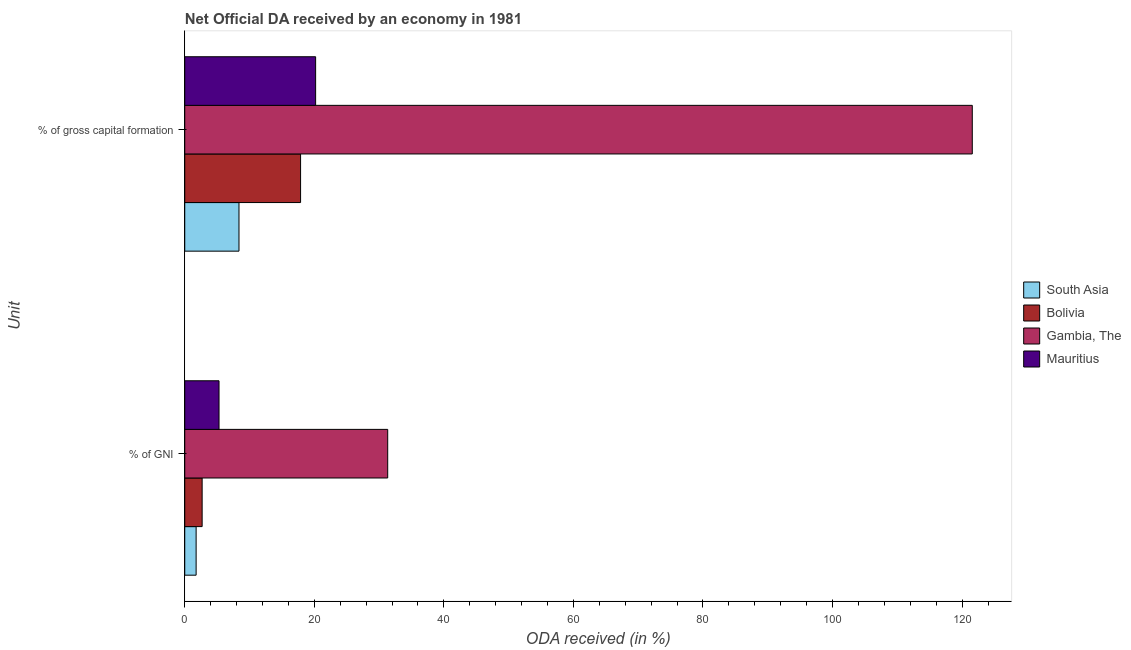Are the number of bars on each tick of the Y-axis equal?
Provide a succinct answer. Yes. What is the label of the 1st group of bars from the top?
Make the answer very short. % of gross capital formation. What is the oda received as percentage of gross capital formation in Bolivia?
Offer a terse response. 17.88. Across all countries, what is the maximum oda received as percentage of gni?
Your response must be concise. 31.33. Across all countries, what is the minimum oda received as percentage of gross capital formation?
Ensure brevity in your answer.  8.37. In which country was the oda received as percentage of gni maximum?
Make the answer very short. Gambia, The. In which country was the oda received as percentage of gni minimum?
Offer a very short reply. South Asia. What is the total oda received as percentage of gross capital formation in the graph?
Give a very brief answer. 168.03. What is the difference between the oda received as percentage of gross capital formation in Gambia, The and that in Bolivia?
Offer a terse response. 103.7. What is the difference between the oda received as percentage of gni in Bolivia and the oda received as percentage of gross capital formation in Gambia, The?
Ensure brevity in your answer.  -118.89. What is the average oda received as percentage of gni per country?
Keep it short and to the point. 10.27. What is the difference between the oda received as percentage of gni and oda received as percentage of gross capital formation in South Asia?
Provide a succinct answer. -6.62. What is the ratio of the oda received as percentage of gross capital formation in South Asia to that in Mauritius?
Your response must be concise. 0.41. What does the 2nd bar from the top in % of GNI represents?
Ensure brevity in your answer.  Gambia, The. How many bars are there?
Your answer should be compact. 8. Are all the bars in the graph horizontal?
Make the answer very short. Yes. Are the values on the major ticks of X-axis written in scientific E-notation?
Keep it short and to the point. No. Where does the legend appear in the graph?
Your response must be concise. Center right. How many legend labels are there?
Offer a very short reply. 4. What is the title of the graph?
Provide a short and direct response. Net Official DA received by an economy in 1981. Does "Mongolia" appear as one of the legend labels in the graph?
Give a very brief answer. No. What is the label or title of the X-axis?
Provide a short and direct response. ODA received (in %). What is the label or title of the Y-axis?
Provide a succinct answer. Unit. What is the ODA received (in %) in South Asia in % of GNI?
Ensure brevity in your answer.  1.76. What is the ODA received (in %) of Bolivia in % of GNI?
Your answer should be very brief. 2.68. What is the ODA received (in %) of Gambia, The in % of GNI?
Ensure brevity in your answer.  31.33. What is the ODA received (in %) of Mauritius in % of GNI?
Provide a short and direct response. 5.29. What is the ODA received (in %) in South Asia in % of gross capital formation?
Provide a short and direct response. 8.37. What is the ODA received (in %) of Bolivia in % of gross capital formation?
Your answer should be very brief. 17.88. What is the ODA received (in %) of Gambia, The in % of gross capital formation?
Provide a short and direct response. 121.58. What is the ODA received (in %) of Mauritius in % of gross capital formation?
Your answer should be compact. 20.2. Across all Unit, what is the maximum ODA received (in %) of South Asia?
Your answer should be compact. 8.37. Across all Unit, what is the maximum ODA received (in %) of Bolivia?
Your answer should be very brief. 17.88. Across all Unit, what is the maximum ODA received (in %) of Gambia, The?
Provide a short and direct response. 121.58. Across all Unit, what is the maximum ODA received (in %) of Mauritius?
Your answer should be compact. 20.2. Across all Unit, what is the minimum ODA received (in %) of South Asia?
Ensure brevity in your answer.  1.76. Across all Unit, what is the minimum ODA received (in %) in Bolivia?
Provide a succinct answer. 2.68. Across all Unit, what is the minimum ODA received (in %) in Gambia, The?
Your answer should be compact. 31.33. Across all Unit, what is the minimum ODA received (in %) of Mauritius?
Ensure brevity in your answer.  5.29. What is the total ODA received (in %) of South Asia in the graph?
Your response must be concise. 10.13. What is the total ODA received (in %) of Bolivia in the graph?
Offer a very short reply. 20.56. What is the total ODA received (in %) of Gambia, The in the graph?
Offer a very short reply. 152.91. What is the total ODA received (in %) of Mauritius in the graph?
Make the answer very short. 25.49. What is the difference between the ODA received (in %) of South Asia in % of GNI and that in % of gross capital formation?
Provide a succinct answer. -6.62. What is the difference between the ODA received (in %) in Bolivia in % of GNI and that in % of gross capital formation?
Keep it short and to the point. -15.19. What is the difference between the ODA received (in %) in Gambia, The in % of GNI and that in % of gross capital formation?
Give a very brief answer. -90.24. What is the difference between the ODA received (in %) of Mauritius in % of GNI and that in % of gross capital formation?
Provide a short and direct response. -14.91. What is the difference between the ODA received (in %) in South Asia in % of GNI and the ODA received (in %) in Bolivia in % of gross capital formation?
Provide a short and direct response. -16.12. What is the difference between the ODA received (in %) of South Asia in % of GNI and the ODA received (in %) of Gambia, The in % of gross capital formation?
Keep it short and to the point. -119.82. What is the difference between the ODA received (in %) of South Asia in % of GNI and the ODA received (in %) of Mauritius in % of gross capital formation?
Your answer should be very brief. -18.45. What is the difference between the ODA received (in %) of Bolivia in % of GNI and the ODA received (in %) of Gambia, The in % of gross capital formation?
Keep it short and to the point. -118.89. What is the difference between the ODA received (in %) of Bolivia in % of GNI and the ODA received (in %) of Mauritius in % of gross capital formation?
Make the answer very short. -17.52. What is the difference between the ODA received (in %) in Gambia, The in % of GNI and the ODA received (in %) in Mauritius in % of gross capital formation?
Keep it short and to the point. 11.13. What is the average ODA received (in %) in South Asia per Unit?
Provide a succinct answer. 5.06. What is the average ODA received (in %) of Bolivia per Unit?
Offer a very short reply. 10.28. What is the average ODA received (in %) of Gambia, The per Unit?
Provide a short and direct response. 76.45. What is the average ODA received (in %) in Mauritius per Unit?
Your response must be concise. 12.75. What is the difference between the ODA received (in %) of South Asia and ODA received (in %) of Bolivia in % of GNI?
Offer a terse response. -0.93. What is the difference between the ODA received (in %) of South Asia and ODA received (in %) of Gambia, The in % of GNI?
Give a very brief answer. -29.58. What is the difference between the ODA received (in %) in South Asia and ODA received (in %) in Mauritius in % of GNI?
Offer a terse response. -3.53. What is the difference between the ODA received (in %) in Bolivia and ODA received (in %) in Gambia, The in % of GNI?
Give a very brief answer. -28.65. What is the difference between the ODA received (in %) in Bolivia and ODA received (in %) in Mauritius in % of GNI?
Offer a terse response. -2.61. What is the difference between the ODA received (in %) of Gambia, The and ODA received (in %) of Mauritius in % of GNI?
Ensure brevity in your answer.  26.04. What is the difference between the ODA received (in %) in South Asia and ODA received (in %) in Bolivia in % of gross capital formation?
Keep it short and to the point. -9.51. What is the difference between the ODA received (in %) in South Asia and ODA received (in %) in Gambia, The in % of gross capital formation?
Your answer should be very brief. -113.2. What is the difference between the ODA received (in %) in South Asia and ODA received (in %) in Mauritius in % of gross capital formation?
Provide a short and direct response. -11.83. What is the difference between the ODA received (in %) of Bolivia and ODA received (in %) of Gambia, The in % of gross capital formation?
Make the answer very short. -103.7. What is the difference between the ODA received (in %) in Bolivia and ODA received (in %) in Mauritius in % of gross capital formation?
Your answer should be compact. -2.32. What is the difference between the ODA received (in %) in Gambia, The and ODA received (in %) in Mauritius in % of gross capital formation?
Your answer should be very brief. 101.37. What is the ratio of the ODA received (in %) of South Asia in % of GNI to that in % of gross capital formation?
Provide a short and direct response. 0.21. What is the ratio of the ODA received (in %) of Bolivia in % of GNI to that in % of gross capital formation?
Provide a succinct answer. 0.15. What is the ratio of the ODA received (in %) in Gambia, The in % of GNI to that in % of gross capital formation?
Provide a short and direct response. 0.26. What is the ratio of the ODA received (in %) in Mauritius in % of GNI to that in % of gross capital formation?
Your answer should be very brief. 0.26. What is the difference between the highest and the second highest ODA received (in %) in South Asia?
Ensure brevity in your answer.  6.62. What is the difference between the highest and the second highest ODA received (in %) of Bolivia?
Offer a very short reply. 15.19. What is the difference between the highest and the second highest ODA received (in %) of Gambia, The?
Keep it short and to the point. 90.24. What is the difference between the highest and the second highest ODA received (in %) in Mauritius?
Make the answer very short. 14.91. What is the difference between the highest and the lowest ODA received (in %) of South Asia?
Make the answer very short. 6.62. What is the difference between the highest and the lowest ODA received (in %) in Bolivia?
Your answer should be very brief. 15.19. What is the difference between the highest and the lowest ODA received (in %) of Gambia, The?
Your answer should be very brief. 90.24. What is the difference between the highest and the lowest ODA received (in %) of Mauritius?
Your response must be concise. 14.91. 